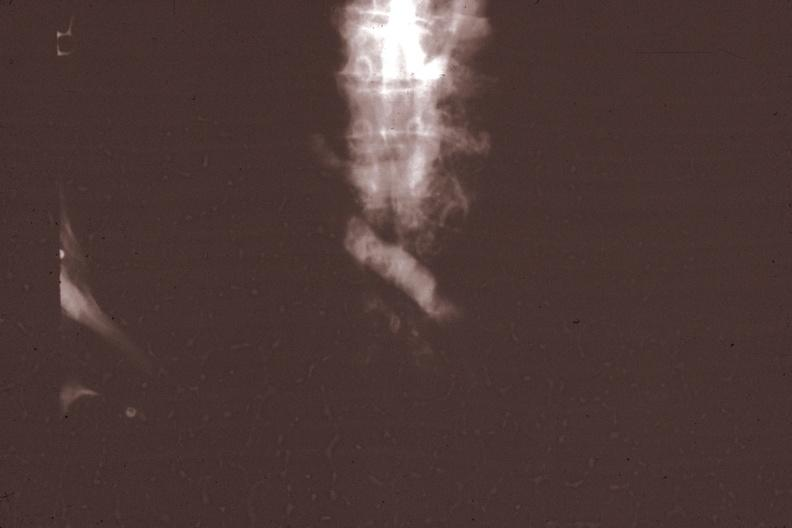does this image show x-ray super cava venogram showing obstruction at level of entrance of innominate vein gross photo of tumor in this file corresponds?
Answer the question using a single word or phrase. Yes 